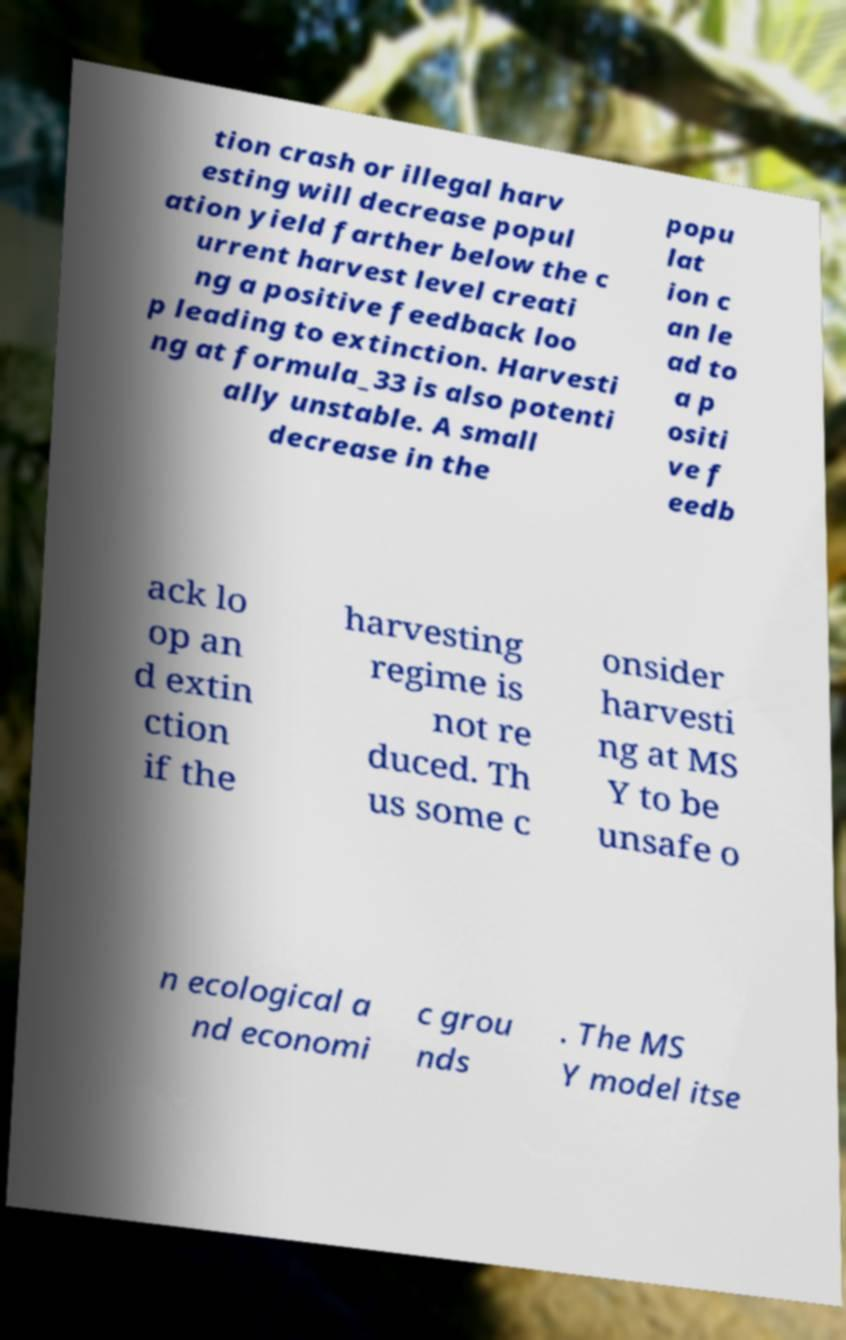There's text embedded in this image that I need extracted. Can you transcribe it verbatim? tion crash or illegal harv esting will decrease popul ation yield farther below the c urrent harvest level creati ng a positive feedback loo p leading to extinction. Harvesti ng at formula_33 is also potenti ally unstable. A small decrease in the popu lat ion c an le ad to a p ositi ve f eedb ack lo op an d extin ction if the harvesting regime is not re duced. Th us some c onsider harvesti ng at MS Y to be unsafe o n ecological a nd economi c grou nds . The MS Y model itse 